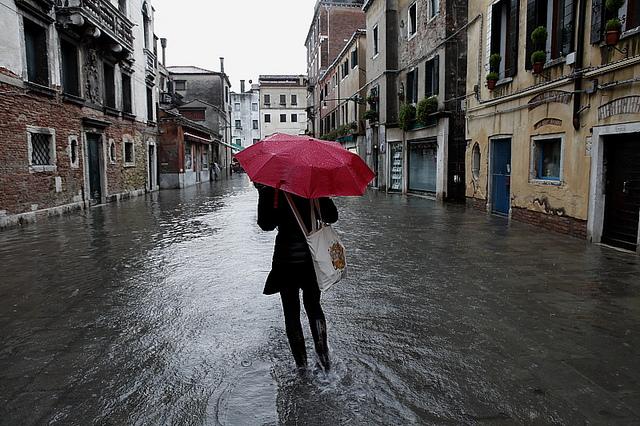What is the woman holding?
Write a very short answer. Umbrella. Is the street flooded?
Answer briefly. Yes. What color is the umbrella?
Keep it brief. Red. 